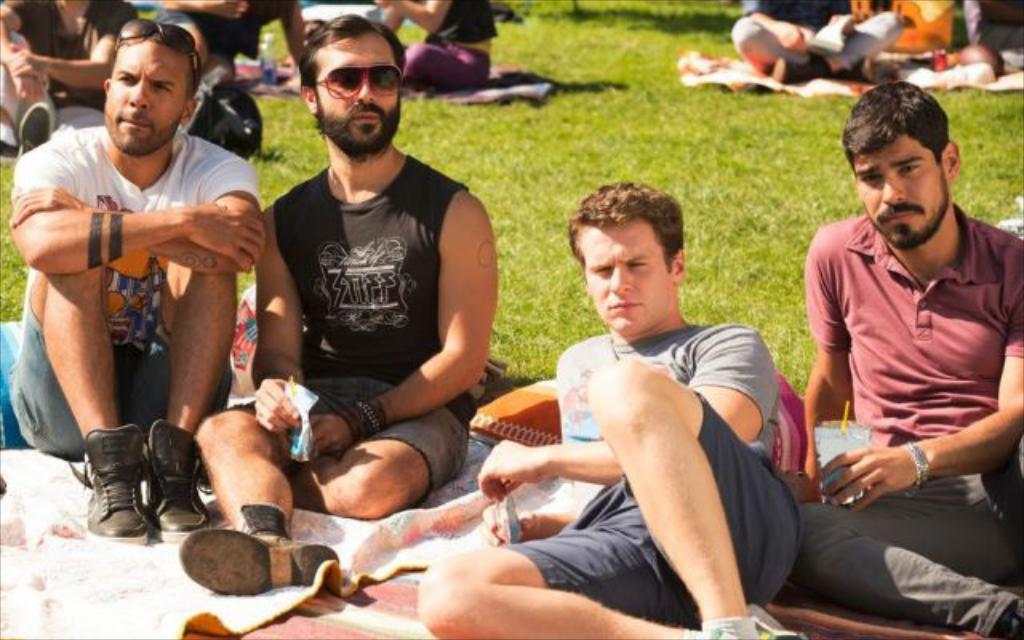Please provide a concise description of this image. As we can see in the image there are clots, grass and group of people. In the front there are four people sitting. The man on the right side is wearing red color t shirt. The man next to him is wearing grey color t shirt. The man sitting on the right side is wearing white color t shirt and shoes. The man next to him is wearing black color t shirt and goggles. 